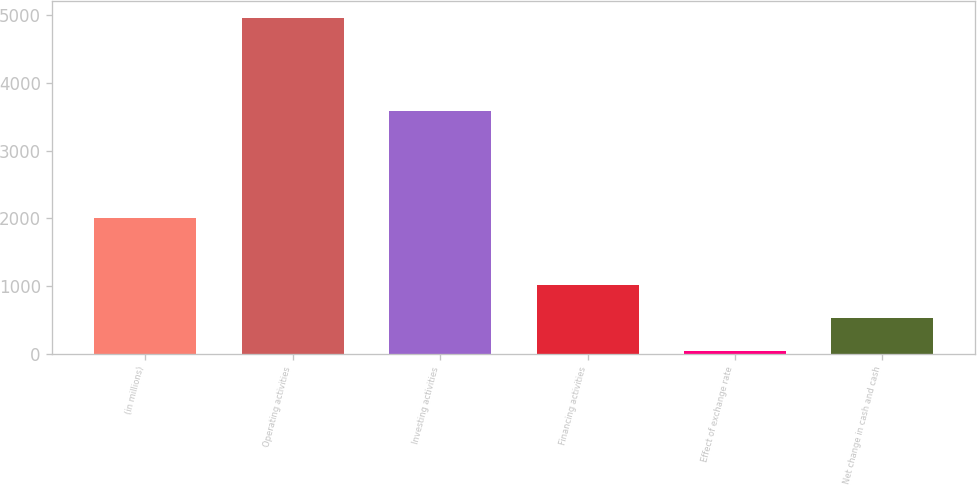<chart> <loc_0><loc_0><loc_500><loc_500><bar_chart><fcel>(in millions)<fcel>Operating activities<fcel>Investing activities<fcel>Financing activities<fcel>Effect of exchange rate<fcel>Net change in cash and cash<nl><fcel>2014<fcel>4959<fcel>3594<fcel>1021.4<fcel>37<fcel>529.2<nl></chart> 